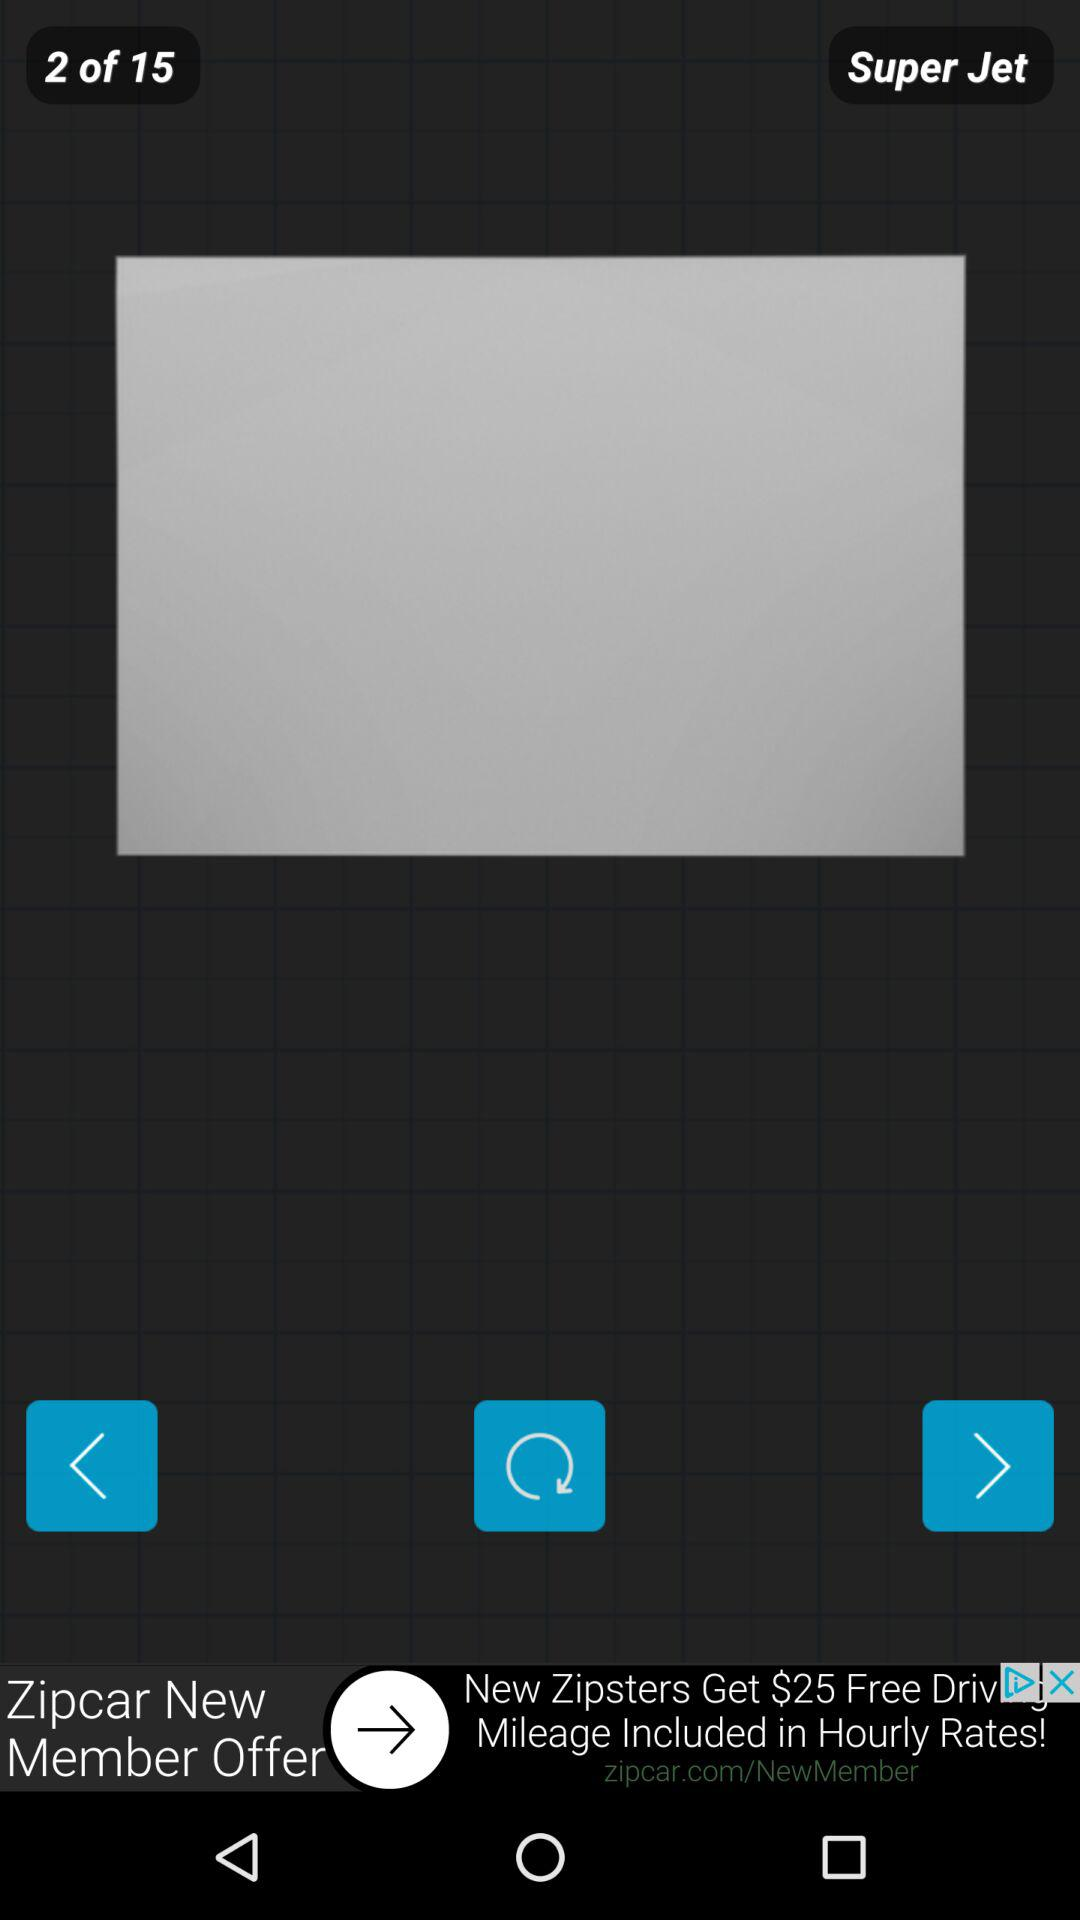On which page am I? You are on the second page. 